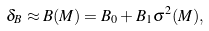Convert formula to latex. <formula><loc_0><loc_0><loc_500><loc_500>\delta _ { B } \approx B ( M ) = B _ { 0 } + B _ { 1 } \sigma ^ { 2 } ( M ) ,</formula> 